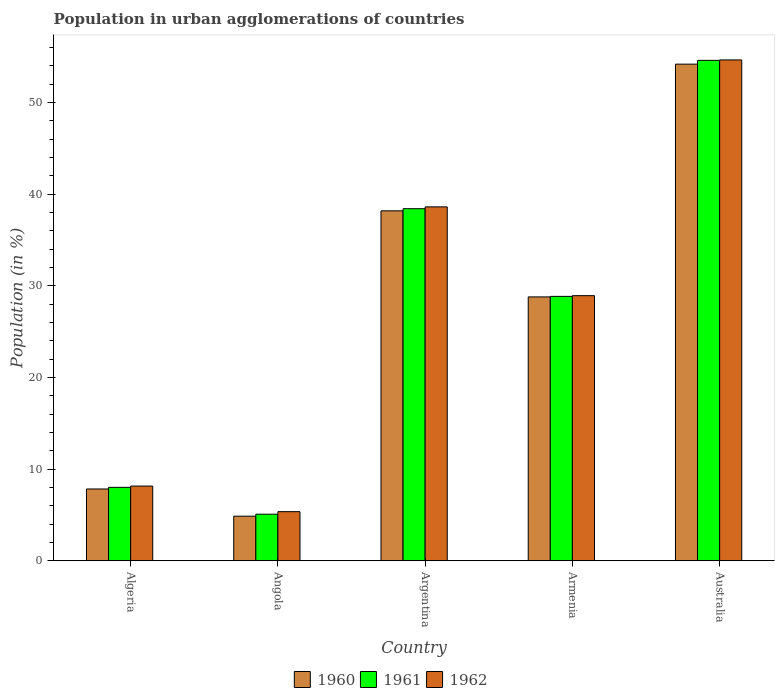How many different coloured bars are there?
Ensure brevity in your answer.  3. Are the number of bars per tick equal to the number of legend labels?
Your response must be concise. Yes. Are the number of bars on each tick of the X-axis equal?
Provide a short and direct response. Yes. How many bars are there on the 2nd tick from the right?
Your answer should be compact. 3. What is the label of the 4th group of bars from the left?
Your answer should be very brief. Armenia. In how many cases, is the number of bars for a given country not equal to the number of legend labels?
Keep it short and to the point. 0. What is the percentage of population in urban agglomerations in 1960 in Argentina?
Make the answer very short. 38.19. Across all countries, what is the maximum percentage of population in urban agglomerations in 1962?
Keep it short and to the point. 54.66. Across all countries, what is the minimum percentage of population in urban agglomerations in 1962?
Your answer should be very brief. 5.36. In which country was the percentage of population in urban agglomerations in 1961 minimum?
Make the answer very short. Angola. What is the total percentage of population in urban agglomerations in 1961 in the graph?
Your answer should be very brief. 134.99. What is the difference between the percentage of population in urban agglomerations in 1961 in Argentina and that in Armenia?
Ensure brevity in your answer.  9.57. What is the difference between the percentage of population in urban agglomerations in 1960 in Argentina and the percentage of population in urban agglomerations in 1962 in Angola?
Offer a terse response. 32.83. What is the average percentage of population in urban agglomerations in 1960 per country?
Give a very brief answer. 26.78. What is the difference between the percentage of population in urban agglomerations of/in 1961 and percentage of population in urban agglomerations of/in 1962 in Angola?
Ensure brevity in your answer.  -0.28. In how many countries, is the percentage of population in urban agglomerations in 1960 greater than 16 %?
Your response must be concise. 3. What is the ratio of the percentage of population in urban agglomerations in 1960 in Angola to that in Australia?
Offer a terse response. 0.09. Is the difference between the percentage of population in urban agglomerations in 1961 in Algeria and Argentina greater than the difference between the percentage of population in urban agglomerations in 1962 in Algeria and Argentina?
Offer a terse response. Yes. What is the difference between the highest and the second highest percentage of population in urban agglomerations in 1962?
Provide a succinct answer. 9.69. What is the difference between the highest and the lowest percentage of population in urban agglomerations in 1960?
Give a very brief answer. 49.33. What does the 1st bar from the left in Angola represents?
Offer a terse response. 1960. Are all the bars in the graph horizontal?
Your answer should be compact. No. Does the graph contain any zero values?
Give a very brief answer. No. What is the title of the graph?
Give a very brief answer. Population in urban agglomerations of countries. What is the label or title of the X-axis?
Ensure brevity in your answer.  Country. What is the Population (in %) of 1960 in Algeria?
Make the answer very short. 7.84. What is the Population (in %) of 1961 in Algeria?
Offer a terse response. 8.01. What is the Population (in %) of 1962 in Algeria?
Your response must be concise. 8.15. What is the Population (in %) of 1960 in Angola?
Your response must be concise. 4.87. What is the Population (in %) in 1961 in Angola?
Offer a very short reply. 5.08. What is the Population (in %) in 1962 in Angola?
Offer a terse response. 5.36. What is the Population (in %) in 1960 in Argentina?
Your response must be concise. 38.19. What is the Population (in %) in 1961 in Argentina?
Provide a short and direct response. 38.42. What is the Population (in %) of 1962 in Argentina?
Give a very brief answer. 38.62. What is the Population (in %) in 1960 in Armenia?
Keep it short and to the point. 28.8. What is the Population (in %) of 1961 in Armenia?
Offer a very short reply. 28.85. What is the Population (in %) of 1962 in Armenia?
Provide a succinct answer. 28.93. What is the Population (in %) of 1960 in Australia?
Provide a short and direct response. 54.2. What is the Population (in %) of 1961 in Australia?
Provide a short and direct response. 54.62. What is the Population (in %) in 1962 in Australia?
Offer a terse response. 54.66. Across all countries, what is the maximum Population (in %) of 1960?
Keep it short and to the point. 54.2. Across all countries, what is the maximum Population (in %) of 1961?
Provide a short and direct response. 54.62. Across all countries, what is the maximum Population (in %) in 1962?
Provide a succinct answer. 54.66. Across all countries, what is the minimum Population (in %) in 1960?
Ensure brevity in your answer.  4.87. Across all countries, what is the minimum Population (in %) in 1961?
Keep it short and to the point. 5.08. Across all countries, what is the minimum Population (in %) in 1962?
Provide a succinct answer. 5.36. What is the total Population (in %) of 1960 in the graph?
Give a very brief answer. 133.89. What is the total Population (in %) of 1961 in the graph?
Make the answer very short. 134.99. What is the total Population (in %) of 1962 in the graph?
Provide a succinct answer. 135.73. What is the difference between the Population (in %) in 1960 in Algeria and that in Angola?
Provide a short and direct response. 2.97. What is the difference between the Population (in %) in 1961 in Algeria and that in Angola?
Give a very brief answer. 2.93. What is the difference between the Population (in %) in 1962 in Algeria and that in Angola?
Give a very brief answer. 2.79. What is the difference between the Population (in %) of 1960 in Algeria and that in Argentina?
Your answer should be very brief. -30.35. What is the difference between the Population (in %) in 1961 in Algeria and that in Argentina?
Your response must be concise. -30.41. What is the difference between the Population (in %) of 1962 in Algeria and that in Argentina?
Provide a short and direct response. -30.47. What is the difference between the Population (in %) in 1960 in Algeria and that in Armenia?
Offer a very short reply. -20.96. What is the difference between the Population (in %) of 1961 in Algeria and that in Armenia?
Provide a short and direct response. -20.84. What is the difference between the Population (in %) of 1962 in Algeria and that in Armenia?
Your response must be concise. -20.78. What is the difference between the Population (in %) of 1960 in Algeria and that in Australia?
Provide a short and direct response. -46.36. What is the difference between the Population (in %) of 1961 in Algeria and that in Australia?
Keep it short and to the point. -46.6. What is the difference between the Population (in %) in 1962 in Algeria and that in Australia?
Provide a short and direct response. -46.51. What is the difference between the Population (in %) of 1960 in Angola and that in Argentina?
Keep it short and to the point. -33.32. What is the difference between the Population (in %) of 1961 in Angola and that in Argentina?
Ensure brevity in your answer.  -33.34. What is the difference between the Population (in %) in 1962 in Angola and that in Argentina?
Provide a short and direct response. -33.26. What is the difference between the Population (in %) in 1960 in Angola and that in Armenia?
Your response must be concise. -23.93. What is the difference between the Population (in %) of 1961 in Angola and that in Armenia?
Offer a terse response. -23.77. What is the difference between the Population (in %) in 1962 in Angola and that in Armenia?
Provide a succinct answer. -23.57. What is the difference between the Population (in %) of 1960 in Angola and that in Australia?
Your answer should be very brief. -49.33. What is the difference between the Population (in %) of 1961 in Angola and that in Australia?
Offer a terse response. -49.53. What is the difference between the Population (in %) of 1962 in Angola and that in Australia?
Give a very brief answer. -49.3. What is the difference between the Population (in %) in 1960 in Argentina and that in Armenia?
Your answer should be compact. 9.39. What is the difference between the Population (in %) in 1961 in Argentina and that in Armenia?
Ensure brevity in your answer.  9.57. What is the difference between the Population (in %) of 1962 in Argentina and that in Armenia?
Make the answer very short. 9.69. What is the difference between the Population (in %) of 1960 in Argentina and that in Australia?
Your response must be concise. -16.01. What is the difference between the Population (in %) of 1961 in Argentina and that in Australia?
Provide a succinct answer. -16.19. What is the difference between the Population (in %) in 1962 in Argentina and that in Australia?
Provide a succinct answer. -16.04. What is the difference between the Population (in %) of 1960 in Armenia and that in Australia?
Ensure brevity in your answer.  -25.4. What is the difference between the Population (in %) of 1961 in Armenia and that in Australia?
Your answer should be compact. -25.76. What is the difference between the Population (in %) of 1962 in Armenia and that in Australia?
Provide a succinct answer. -25.73. What is the difference between the Population (in %) in 1960 in Algeria and the Population (in %) in 1961 in Angola?
Provide a short and direct response. 2.75. What is the difference between the Population (in %) in 1960 in Algeria and the Population (in %) in 1962 in Angola?
Give a very brief answer. 2.48. What is the difference between the Population (in %) of 1961 in Algeria and the Population (in %) of 1962 in Angola?
Ensure brevity in your answer.  2.65. What is the difference between the Population (in %) of 1960 in Algeria and the Population (in %) of 1961 in Argentina?
Offer a very short reply. -30.59. What is the difference between the Population (in %) in 1960 in Algeria and the Population (in %) in 1962 in Argentina?
Offer a very short reply. -30.79. What is the difference between the Population (in %) of 1961 in Algeria and the Population (in %) of 1962 in Argentina?
Your answer should be very brief. -30.61. What is the difference between the Population (in %) of 1960 in Algeria and the Population (in %) of 1961 in Armenia?
Provide a short and direct response. -21.02. What is the difference between the Population (in %) in 1960 in Algeria and the Population (in %) in 1962 in Armenia?
Give a very brief answer. -21.1. What is the difference between the Population (in %) of 1961 in Algeria and the Population (in %) of 1962 in Armenia?
Your answer should be compact. -20.92. What is the difference between the Population (in %) in 1960 in Algeria and the Population (in %) in 1961 in Australia?
Keep it short and to the point. -46.78. What is the difference between the Population (in %) in 1960 in Algeria and the Population (in %) in 1962 in Australia?
Keep it short and to the point. -46.83. What is the difference between the Population (in %) in 1961 in Algeria and the Population (in %) in 1962 in Australia?
Give a very brief answer. -46.65. What is the difference between the Population (in %) in 1960 in Angola and the Population (in %) in 1961 in Argentina?
Provide a succinct answer. -33.56. What is the difference between the Population (in %) of 1960 in Angola and the Population (in %) of 1962 in Argentina?
Your response must be concise. -33.76. What is the difference between the Population (in %) in 1961 in Angola and the Population (in %) in 1962 in Argentina?
Provide a short and direct response. -33.54. What is the difference between the Population (in %) of 1960 in Angola and the Population (in %) of 1961 in Armenia?
Provide a succinct answer. -23.99. What is the difference between the Population (in %) of 1960 in Angola and the Population (in %) of 1962 in Armenia?
Ensure brevity in your answer.  -24.07. What is the difference between the Population (in %) in 1961 in Angola and the Population (in %) in 1962 in Armenia?
Ensure brevity in your answer.  -23.85. What is the difference between the Population (in %) of 1960 in Angola and the Population (in %) of 1961 in Australia?
Keep it short and to the point. -49.75. What is the difference between the Population (in %) in 1960 in Angola and the Population (in %) in 1962 in Australia?
Your answer should be compact. -49.8. What is the difference between the Population (in %) of 1961 in Angola and the Population (in %) of 1962 in Australia?
Provide a short and direct response. -49.58. What is the difference between the Population (in %) of 1960 in Argentina and the Population (in %) of 1961 in Armenia?
Make the answer very short. 9.33. What is the difference between the Population (in %) of 1960 in Argentina and the Population (in %) of 1962 in Armenia?
Give a very brief answer. 9.26. What is the difference between the Population (in %) of 1961 in Argentina and the Population (in %) of 1962 in Armenia?
Give a very brief answer. 9.49. What is the difference between the Population (in %) in 1960 in Argentina and the Population (in %) in 1961 in Australia?
Offer a very short reply. -16.43. What is the difference between the Population (in %) of 1960 in Argentina and the Population (in %) of 1962 in Australia?
Offer a very short reply. -16.47. What is the difference between the Population (in %) in 1961 in Argentina and the Population (in %) in 1962 in Australia?
Provide a succinct answer. -16.24. What is the difference between the Population (in %) of 1960 in Armenia and the Population (in %) of 1961 in Australia?
Make the answer very short. -25.82. What is the difference between the Population (in %) of 1960 in Armenia and the Population (in %) of 1962 in Australia?
Provide a short and direct response. -25.86. What is the difference between the Population (in %) in 1961 in Armenia and the Population (in %) in 1962 in Australia?
Your answer should be compact. -25.81. What is the average Population (in %) in 1960 per country?
Give a very brief answer. 26.78. What is the average Population (in %) in 1961 per country?
Give a very brief answer. 27. What is the average Population (in %) in 1962 per country?
Keep it short and to the point. 27.15. What is the difference between the Population (in %) of 1960 and Population (in %) of 1961 in Algeria?
Your answer should be compact. -0.18. What is the difference between the Population (in %) in 1960 and Population (in %) in 1962 in Algeria?
Your answer should be very brief. -0.32. What is the difference between the Population (in %) of 1961 and Population (in %) of 1962 in Algeria?
Ensure brevity in your answer.  -0.14. What is the difference between the Population (in %) of 1960 and Population (in %) of 1961 in Angola?
Ensure brevity in your answer.  -0.22. What is the difference between the Population (in %) of 1960 and Population (in %) of 1962 in Angola?
Offer a very short reply. -0.49. What is the difference between the Population (in %) in 1961 and Population (in %) in 1962 in Angola?
Give a very brief answer. -0.28. What is the difference between the Population (in %) in 1960 and Population (in %) in 1961 in Argentina?
Keep it short and to the point. -0.23. What is the difference between the Population (in %) of 1960 and Population (in %) of 1962 in Argentina?
Your answer should be compact. -0.43. What is the difference between the Population (in %) in 1961 and Population (in %) in 1962 in Argentina?
Provide a succinct answer. -0.2. What is the difference between the Population (in %) of 1960 and Population (in %) of 1961 in Armenia?
Give a very brief answer. -0.06. What is the difference between the Population (in %) in 1960 and Population (in %) in 1962 in Armenia?
Your answer should be very brief. -0.14. What is the difference between the Population (in %) of 1961 and Population (in %) of 1962 in Armenia?
Offer a terse response. -0.08. What is the difference between the Population (in %) of 1960 and Population (in %) of 1961 in Australia?
Your answer should be compact. -0.42. What is the difference between the Population (in %) of 1960 and Population (in %) of 1962 in Australia?
Offer a very short reply. -0.46. What is the difference between the Population (in %) in 1961 and Population (in %) in 1962 in Australia?
Your response must be concise. -0.05. What is the ratio of the Population (in %) in 1960 in Algeria to that in Angola?
Your answer should be compact. 1.61. What is the ratio of the Population (in %) in 1961 in Algeria to that in Angola?
Offer a very short reply. 1.58. What is the ratio of the Population (in %) in 1962 in Algeria to that in Angola?
Make the answer very short. 1.52. What is the ratio of the Population (in %) of 1960 in Algeria to that in Argentina?
Make the answer very short. 0.21. What is the ratio of the Population (in %) of 1961 in Algeria to that in Argentina?
Make the answer very short. 0.21. What is the ratio of the Population (in %) of 1962 in Algeria to that in Argentina?
Keep it short and to the point. 0.21. What is the ratio of the Population (in %) in 1960 in Algeria to that in Armenia?
Your answer should be very brief. 0.27. What is the ratio of the Population (in %) in 1961 in Algeria to that in Armenia?
Give a very brief answer. 0.28. What is the ratio of the Population (in %) of 1962 in Algeria to that in Armenia?
Provide a short and direct response. 0.28. What is the ratio of the Population (in %) in 1960 in Algeria to that in Australia?
Keep it short and to the point. 0.14. What is the ratio of the Population (in %) in 1961 in Algeria to that in Australia?
Make the answer very short. 0.15. What is the ratio of the Population (in %) of 1962 in Algeria to that in Australia?
Your answer should be compact. 0.15. What is the ratio of the Population (in %) in 1960 in Angola to that in Argentina?
Keep it short and to the point. 0.13. What is the ratio of the Population (in %) in 1961 in Angola to that in Argentina?
Ensure brevity in your answer.  0.13. What is the ratio of the Population (in %) of 1962 in Angola to that in Argentina?
Give a very brief answer. 0.14. What is the ratio of the Population (in %) of 1960 in Angola to that in Armenia?
Provide a succinct answer. 0.17. What is the ratio of the Population (in %) of 1961 in Angola to that in Armenia?
Provide a short and direct response. 0.18. What is the ratio of the Population (in %) in 1962 in Angola to that in Armenia?
Offer a terse response. 0.19. What is the ratio of the Population (in %) of 1960 in Angola to that in Australia?
Provide a succinct answer. 0.09. What is the ratio of the Population (in %) in 1961 in Angola to that in Australia?
Your answer should be compact. 0.09. What is the ratio of the Population (in %) in 1962 in Angola to that in Australia?
Offer a very short reply. 0.1. What is the ratio of the Population (in %) in 1960 in Argentina to that in Armenia?
Provide a succinct answer. 1.33. What is the ratio of the Population (in %) of 1961 in Argentina to that in Armenia?
Ensure brevity in your answer.  1.33. What is the ratio of the Population (in %) in 1962 in Argentina to that in Armenia?
Keep it short and to the point. 1.33. What is the ratio of the Population (in %) of 1960 in Argentina to that in Australia?
Keep it short and to the point. 0.7. What is the ratio of the Population (in %) in 1961 in Argentina to that in Australia?
Provide a succinct answer. 0.7. What is the ratio of the Population (in %) in 1962 in Argentina to that in Australia?
Keep it short and to the point. 0.71. What is the ratio of the Population (in %) of 1960 in Armenia to that in Australia?
Offer a very short reply. 0.53. What is the ratio of the Population (in %) of 1961 in Armenia to that in Australia?
Your answer should be compact. 0.53. What is the ratio of the Population (in %) of 1962 in Armenia to that in Australia?
Offer a terse response. 0.53. What is the difference between the highest and the second highest Population (in %) in 1960?
Your response must be concise. 16.01. What is the difference between the highest and the second highest Population (in %) of 1961?
Ensure brevity in your answer.  16.19. What is the difference between the highest and the second highest Population (in %) of 1962?
Your response must be concise. 16.04. What is the difference between the highest and the lowest Population (in %) in 1960?
Offer a terse response. 49.33. What is the difference between the highest and the lowest Population (in %) of 1961?
Offer a very short reply. 49.53. What is the difference between the highest and the lowest Population (in %) of 1962?
Your response must be concise. 49.3. 